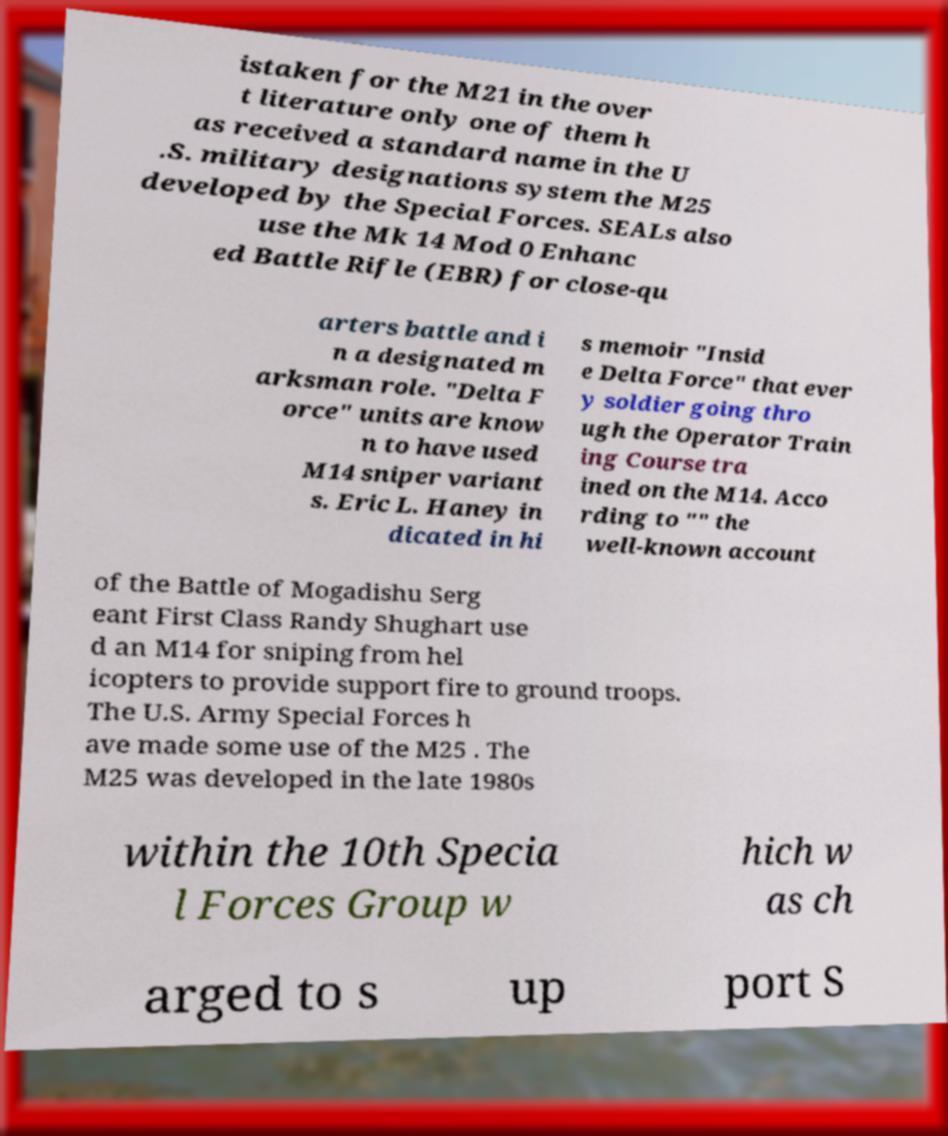I need the written content from this picture converted into text. Can you do that? istaken for the M21 in the over t literature only one of them h as received a standard name in the U .S. military designations system the M25 developed by the Special Forces. SEALs also use the Mk 14 Mod 0 Enhanc ed Battle Rifle (EBR) for close-qu arters battle and i n a designated m arksman role. "Delta F orce" units are know n to have used M14 sniper variant s. Eric L. Haney in dicated in hi s memoir "Insid e Delta Force" that ever y soldier going thro ugh the Operator Train ing Course tra ined on the M14. Acco rding to "" the well-known account of the Battle of Mogadishu Serg eant First Class Randy Shughart use d an M14 for sniping from hel icopters to provide support fire to ground troops. The U.S. Army Special Forces h ave made some use of the M25 . The M25 was developed in the late 1980s within the 10th Specia l Forces Group w hich w as ch arged to s up port S 